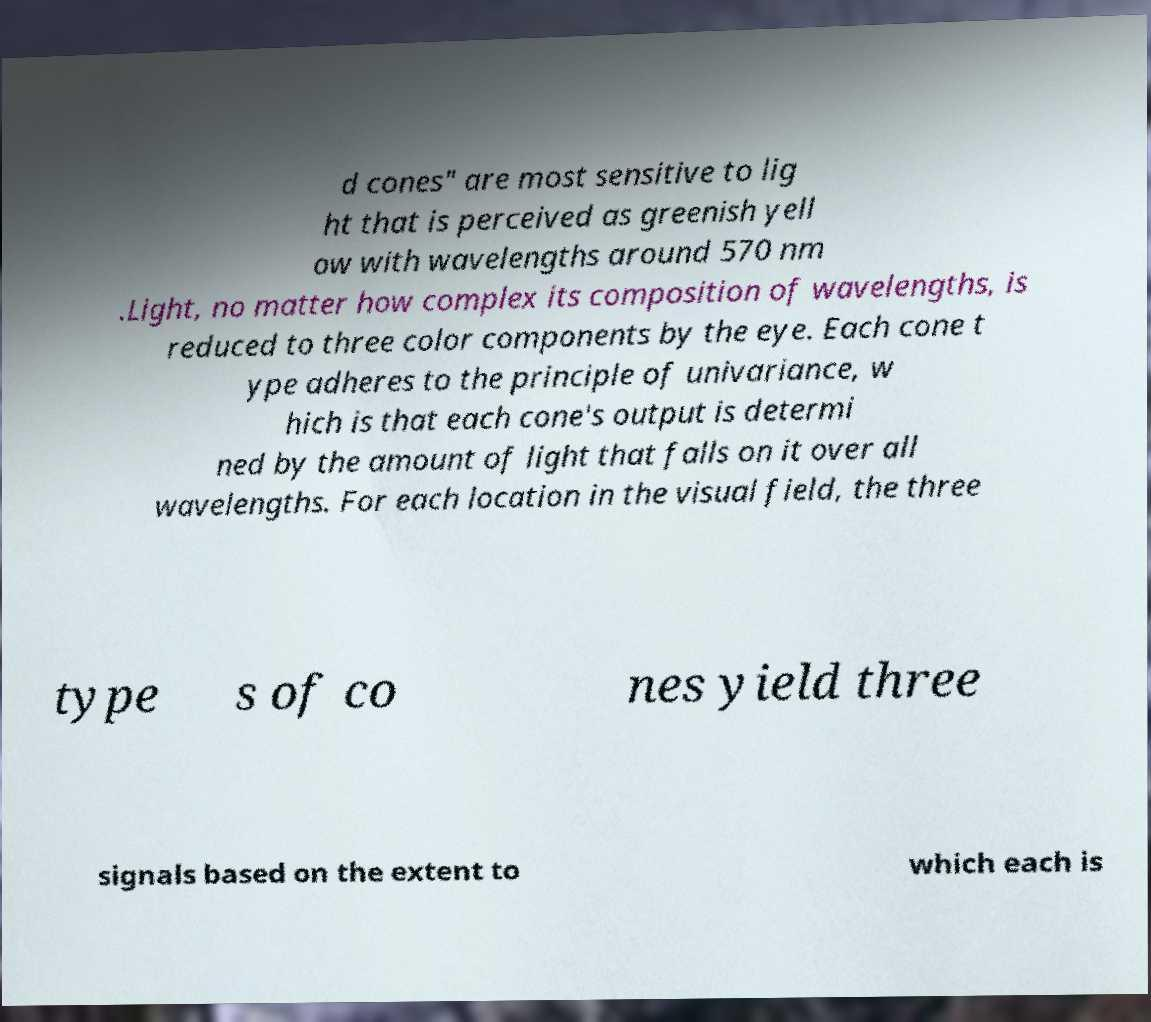What messages or text are displayed in this image? I need them in a readable, typed format. d cones" are most sensitive to lig ht that is perceived as greenish yell ow with wavelengths around 570 nm .Light, no matter how complex its composition of wavelengths, is reduced to three color components by the eye. Each cone t ype adheres to the principle of univariance, w hich is that each cone's output is determi ned by the amount of light that falls on it over all wavelengths. For each location in the visual field, the three type s of co nes yield three signals based on the extent to which each is 